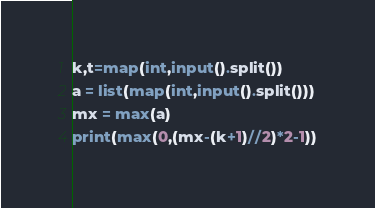<code> <loc_0><loc_0><loc_500><loc_500><_Python_>k,t=map(int,input().split())
a = list(map(int,input().split()))
mx = max(a)
print(max(0,(mx-(k+1)//2)*2-1))</code> 